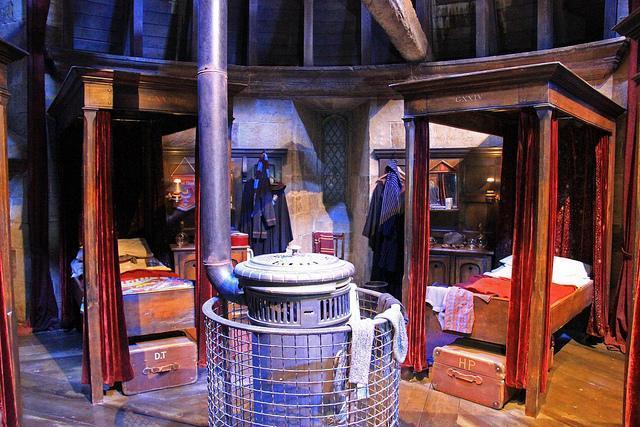How many suitcases can be seen?
Give a very brief answer. 2. How many beds can you see?
Give a very brief answer. 2. 